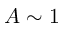Convert formula to latex. <formula><loc_0><loc_0><loc_500><loc_500>A \sim 1</formula> 